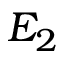<formula> <loc_0><loc_0><loc_500><loc_500>E _ { 2 }</formula> 